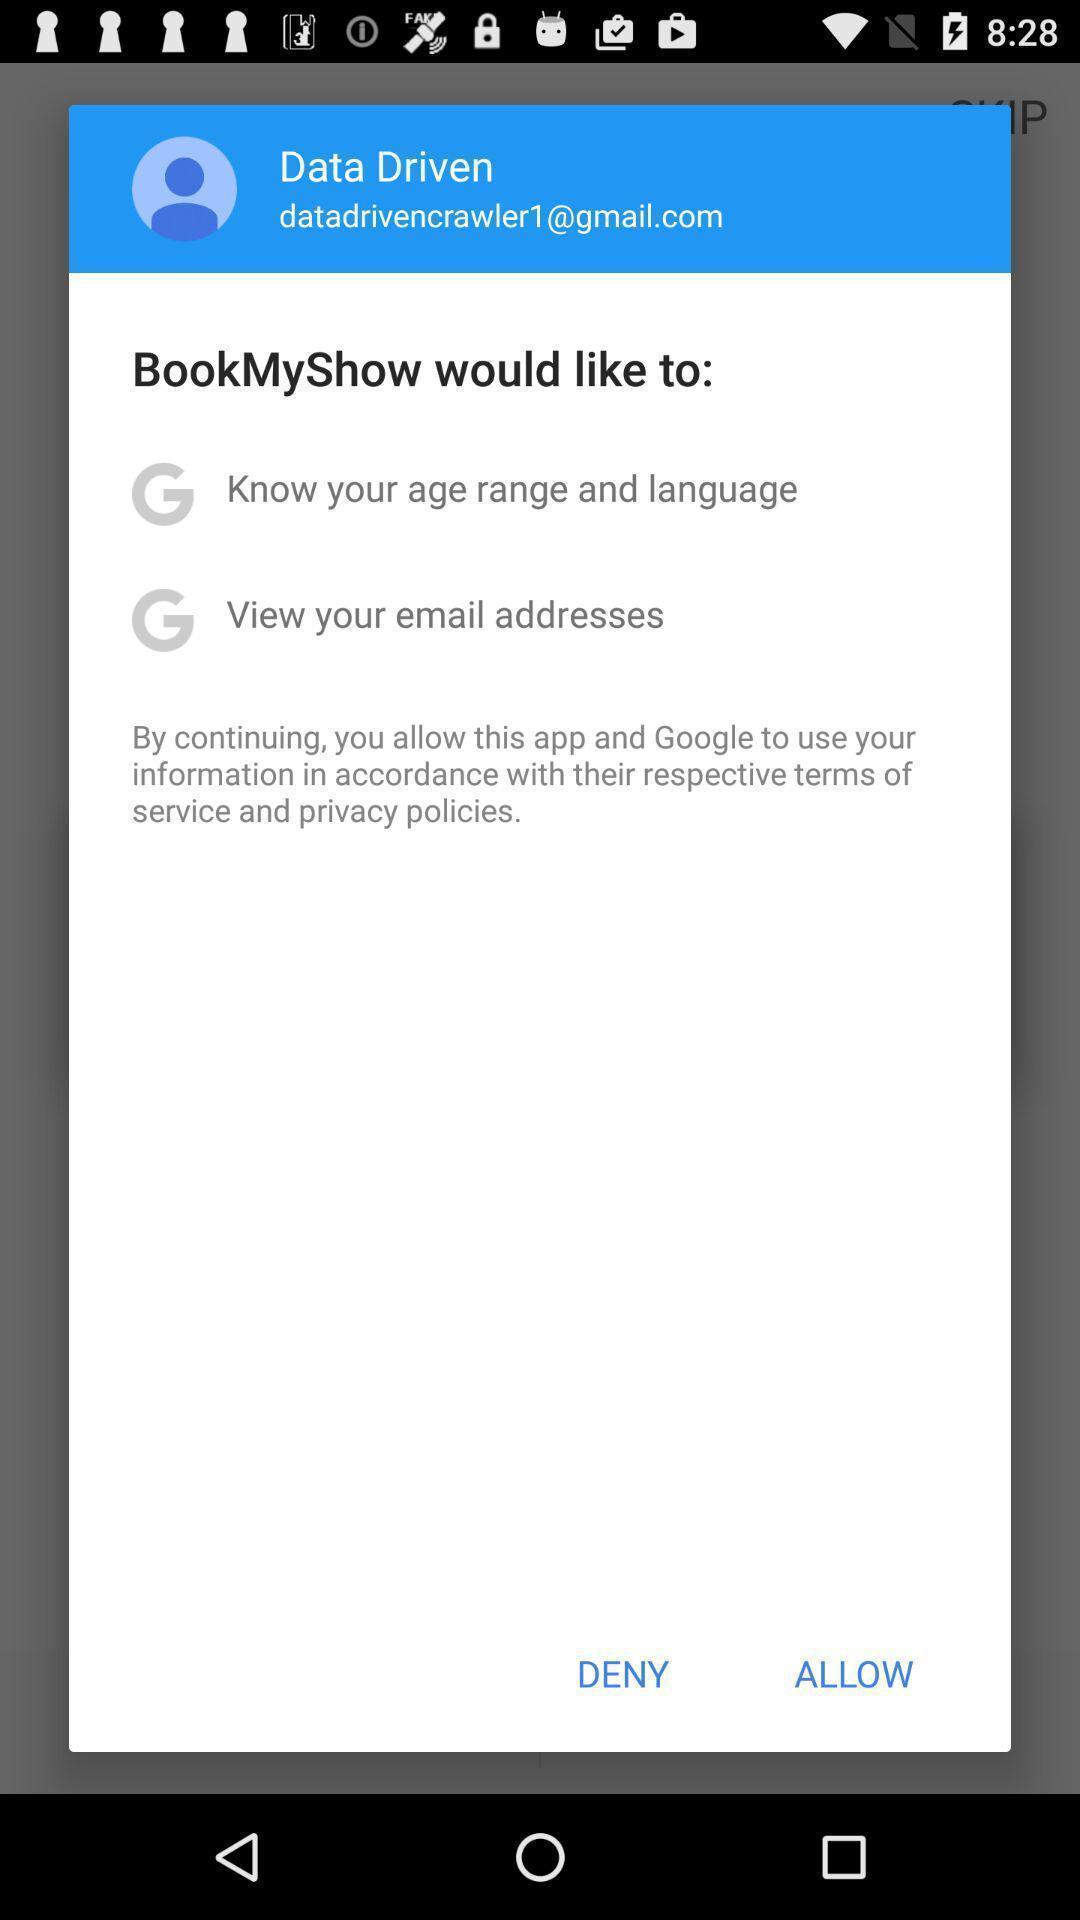Please provide a description for this image. Pop-up asking to grant information access. 